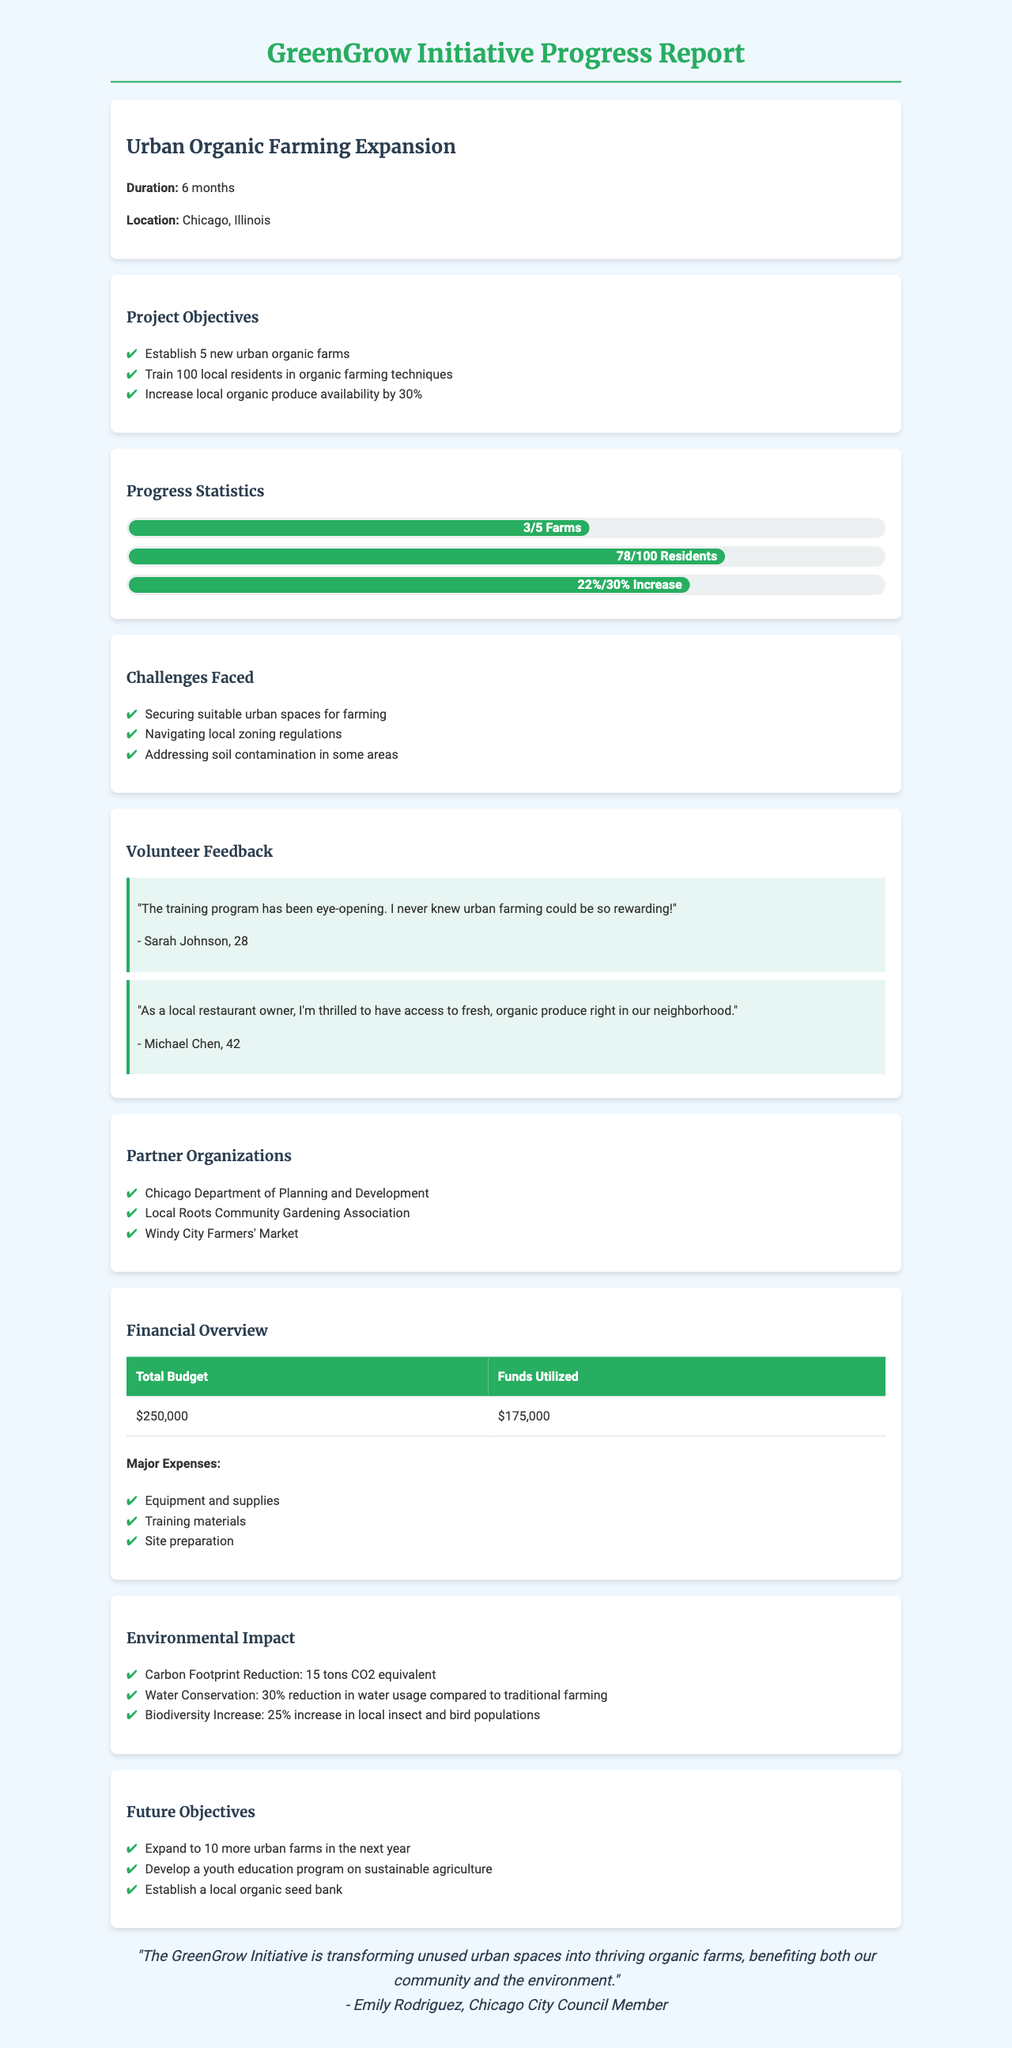what is the name of the project? The project is titled "Urban Organic Farming Expansion."
Answer: Urban Organic Farming Expansion how many farms have been established? The document states that 3 urban organic farms have been established so far.
Answer: 3 what percentage increase in organic produce was achieved? The progress report mentions a 22% increase in organic produce.
Answer: 22% what was the total budget for the initiative? The total budget for the GreenGrow Initiative is $250,000.
Answer: $250,000 who provided feedback about the training program? Feedback was provided by volunteers including Sarah Johnson and Michael Chen.
Answer: Sarah Johnson and Michael Chen what is one of the major challenges faced? The report identifies several challenges, including securing suitable urban spaces for farming.
Answer: Securing suitable urban spaces for farming how much was utilized of the total budget? The funds utilized so far amount to $175,000.
Answer: $175,000 what is the goal for resident training in the coming year? The future objective includes training 100 local residents in organic farming techniques.
Answer: Training 100 local residents who is quoted in the testimonial? The testimonial is from Emily Rodriguez, a Chicago City Council Member.
Answer: Emily Rodriguez 